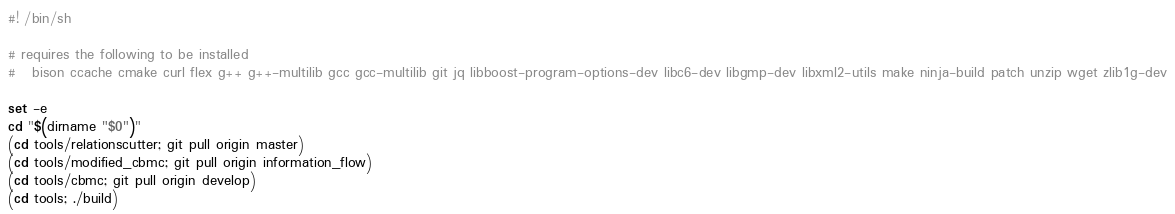Convert code to text. <code><loc_0><loc_0><loc_500><loc_500><_Bash_>#! /bin/sh

# requires the following to be installed
#   bison ccache cmake curl flex g++ g++-multilib gcc gcc-multilib git jq libboost-program-options-dev libc6-dev libgmp-dev libxml2-utils make ninja-build patch unzip wget zlib1g-dev

set -e
cd "$(dirname "$0")"
(cd tools/relationscutter; git pull origin master)
(cd tools/modified_cbmc; git pull origin information_flow)
(cd tools/cbmc; git pull origin develop)
(cd tools; ./build)
</code> 